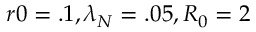Convert formula to latex. <formula><loc_0><loc_0><loc_500><loc_500>r 0 = . 1 , \lambda _ { N } = . 0 5 , R _ { 0 } = 2</formula> 